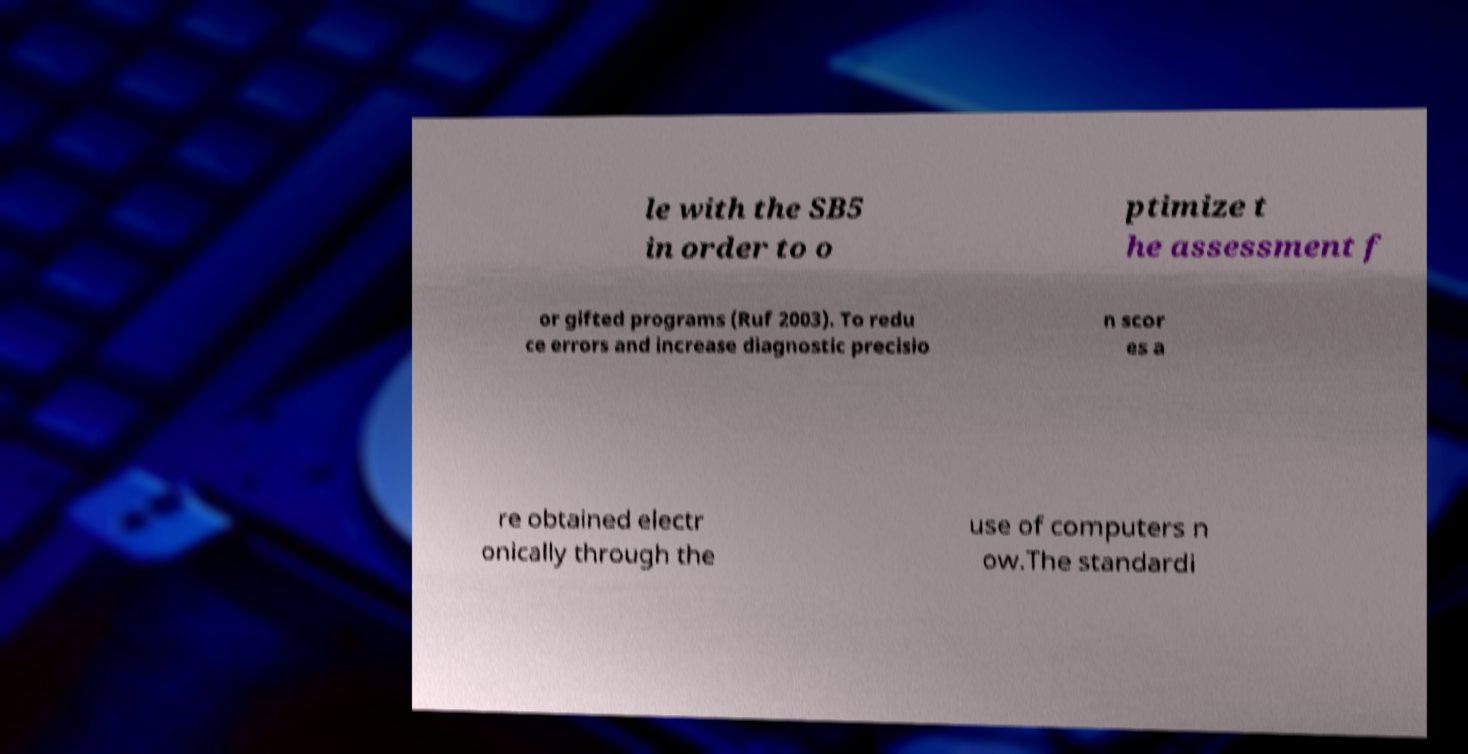There's text embedded in this image that I need extracted. Can you transcribe it verbatim? le with the SB5 in order to o ptimize t he assessment f or gifted programs (Ruf 2003). To redu ce errors and increase diagnostic precisio n scor es a re obtained electr onically through the use of computers n ow.The standardi 